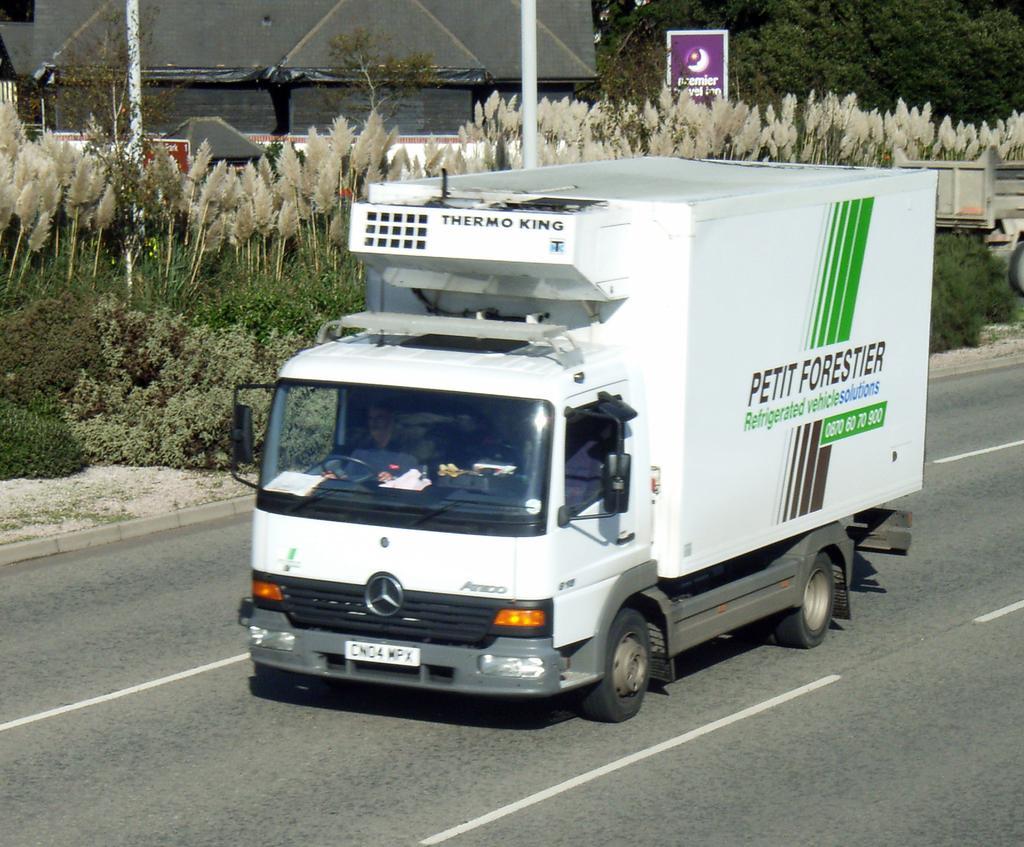Could you give a brief overview of what you see in this image? In this image, we can see a van on the road and there is man inside the van. In the background, there are trees, plants, poles, boards and there is a shed. 